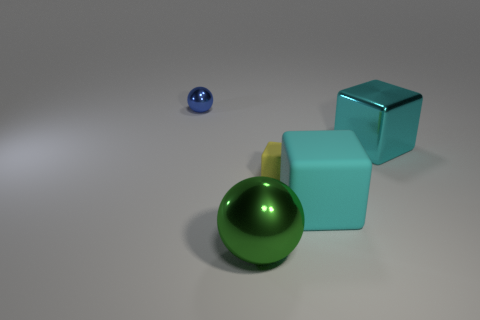Are there any other things that are the same shape as the blue thing?
Make the answer very short. Yes. Are there the same number of large cyan objects right of the tiny rubber block and big cyan things that are to the left of the small blue metallic object?
Ensure brevity in your answer.  No. What number of blocks are either yellow objects or shiny things?
Your response must be concise. 2. What number of other objects are the same material as the tiny cube?
Keep it short and to the point. 1. The thing that is to the left of the large green object has what shape?
Give a very brief answer. Sphere. There is a large block to the left of the cyan metal block behind the yellow matte cube; what is its material?
Give a very brief answer. Rubber. Is the number of small balls that are on the right side of the tiny sphere greater than the number of red things?
Offer a very short reply. No. What number of other objects are the same color as the small cube?
Give a very brief answer. 0. What is the shape of the yellow object that is the same size as the blue shiny thing?
Give a very brief answer. Cube. How many tiny rubber cubes are behind the big shiny object that is right of the rubber object left of the big cyan matte thing?
Provide a short and direct response. 0. 